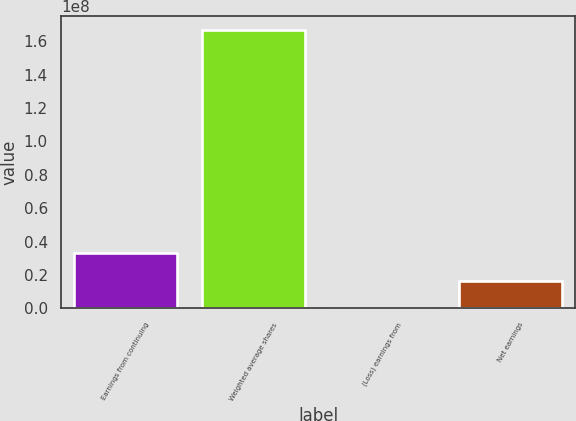<chart> <loc_0><loc_0><loc_500><loc_500><bar_chart><fcel>Earnings from continuing<fcel>Weighted average shares<fcel>(Loss) earnings from<fcel>Net earnings<nl><fcel>3.33384e+07<fcel>1.66692e+08<fcel>0.02<fcel>1.66692e+07<nl></chart> 